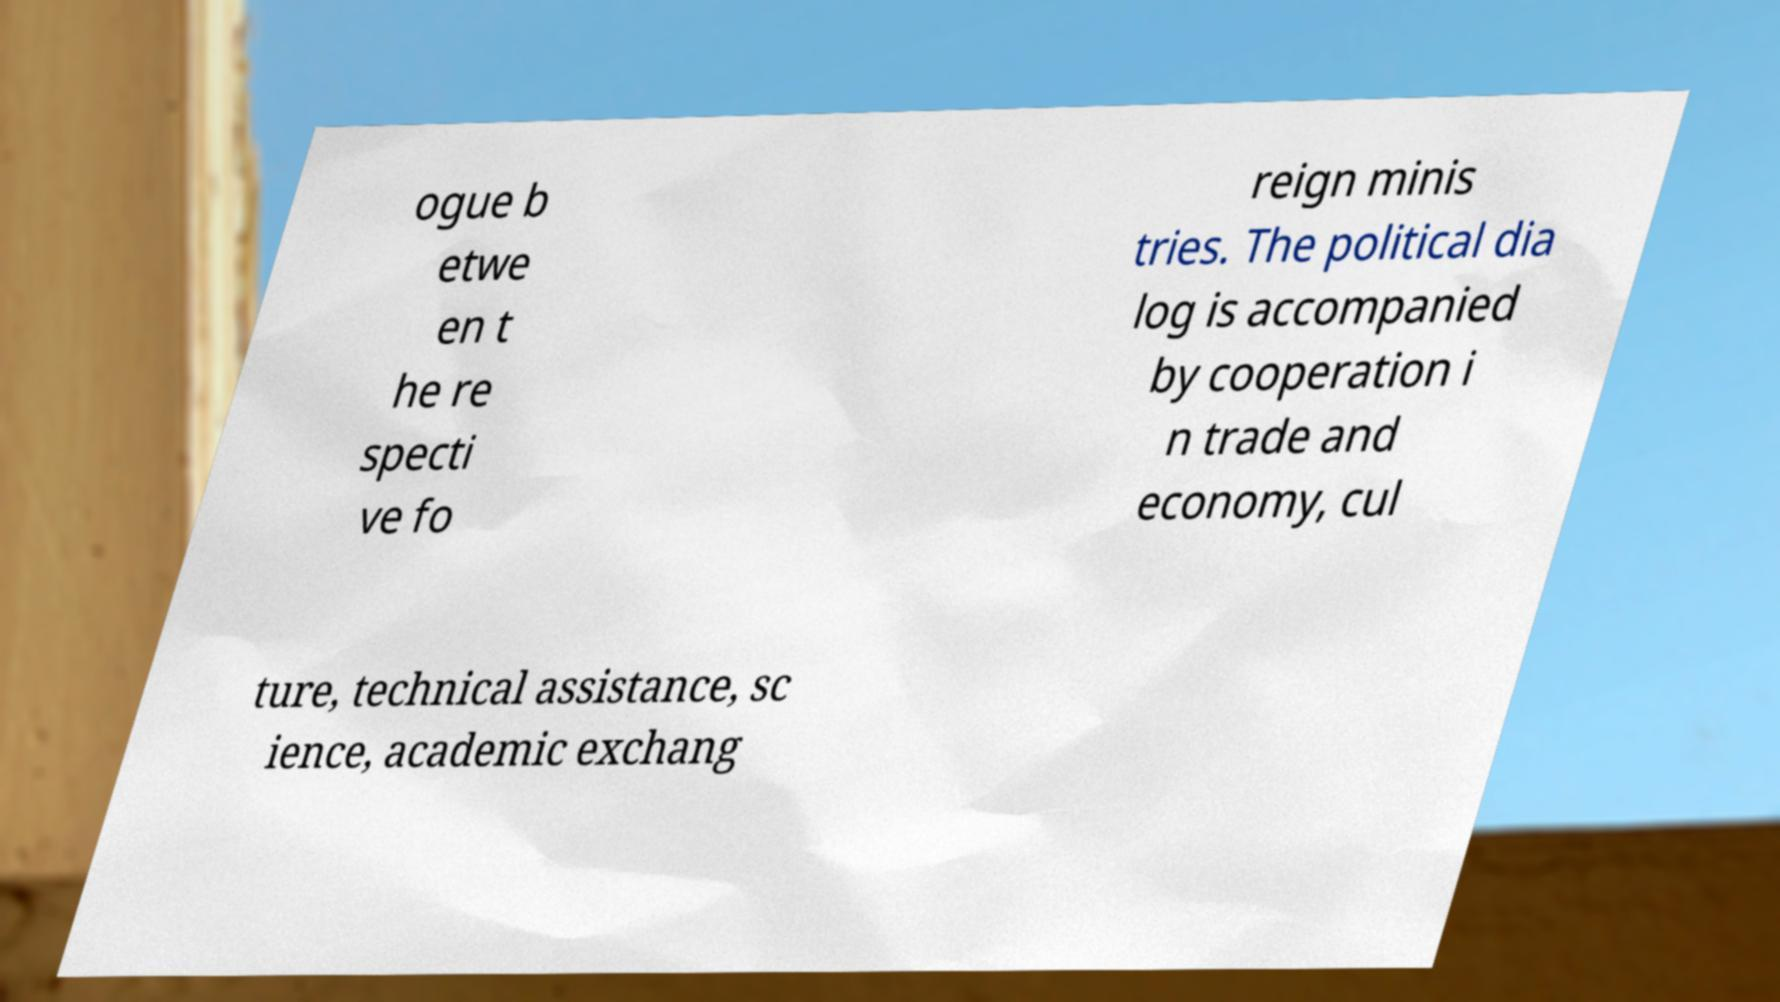Please identify and transcribe the text found in this image. ogue b etwe en t he re specti ve fo reign minis tries. The political dia log is accompanied by cooperation i n trade and economy, cul ture, technical assistance, sc ience, academic exchang 